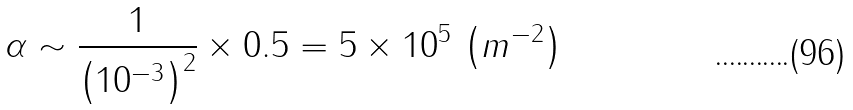<formula> <loc_0><loc_0><loc_500><loc_500>\alpha \sim \frac { 1 } { \left ( 1 0 ^ { - 3 } \right ) ^ { 2 } } \times 0 . 5 = 5 \times 1 0 ^ { 5 } \, \left ( m ^ { - 2 } \right )</formula> 